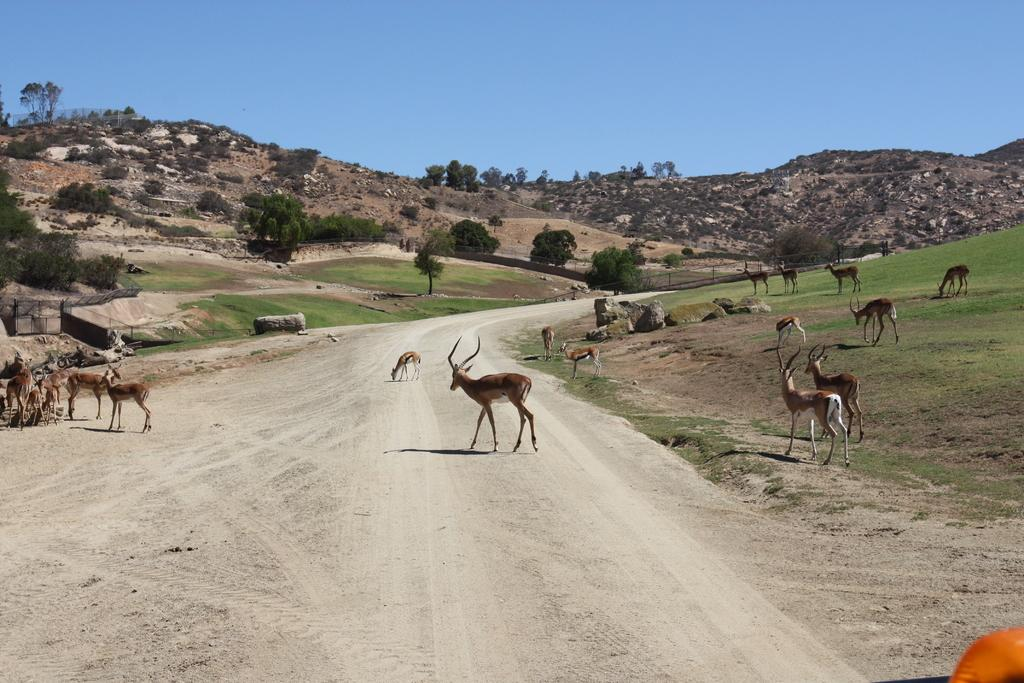What animals can be seen on the road in the image? There are deer on the road in the image. Where else can deer be seen in the image? Deer can also be seen on the grass in the image. What type of natural features are visible in the image? Rocks and trees are visible in the image. What can be seen in the background of the image? There are hills and a blue sky in the background of the image. Can you see any boats in the ocean in the image? There is no ocean or boats present in the image. Are there any ants visible on the grass in the image? There is no mention of ants in the image, only deer. 